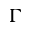<formula> <loc_0><loc_0><loc_500><loc_500>\Gamma</formula> 